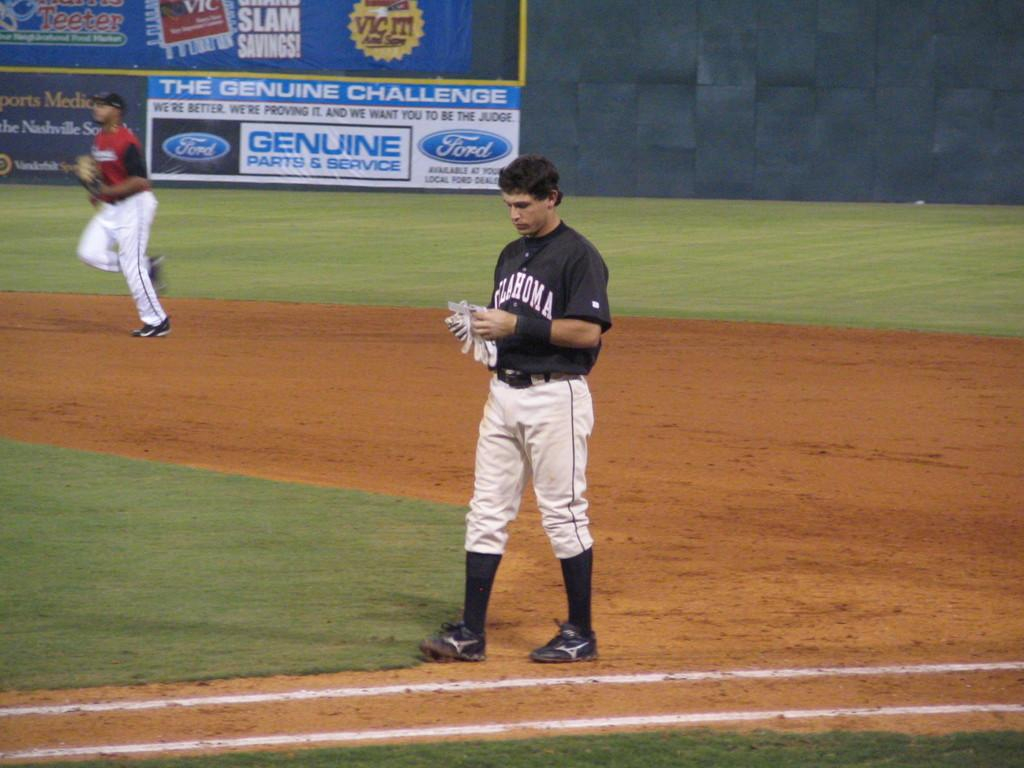Provide a one-sentence caption for the provided image. An Oklahoma baseball player takes his batting gloves off. 